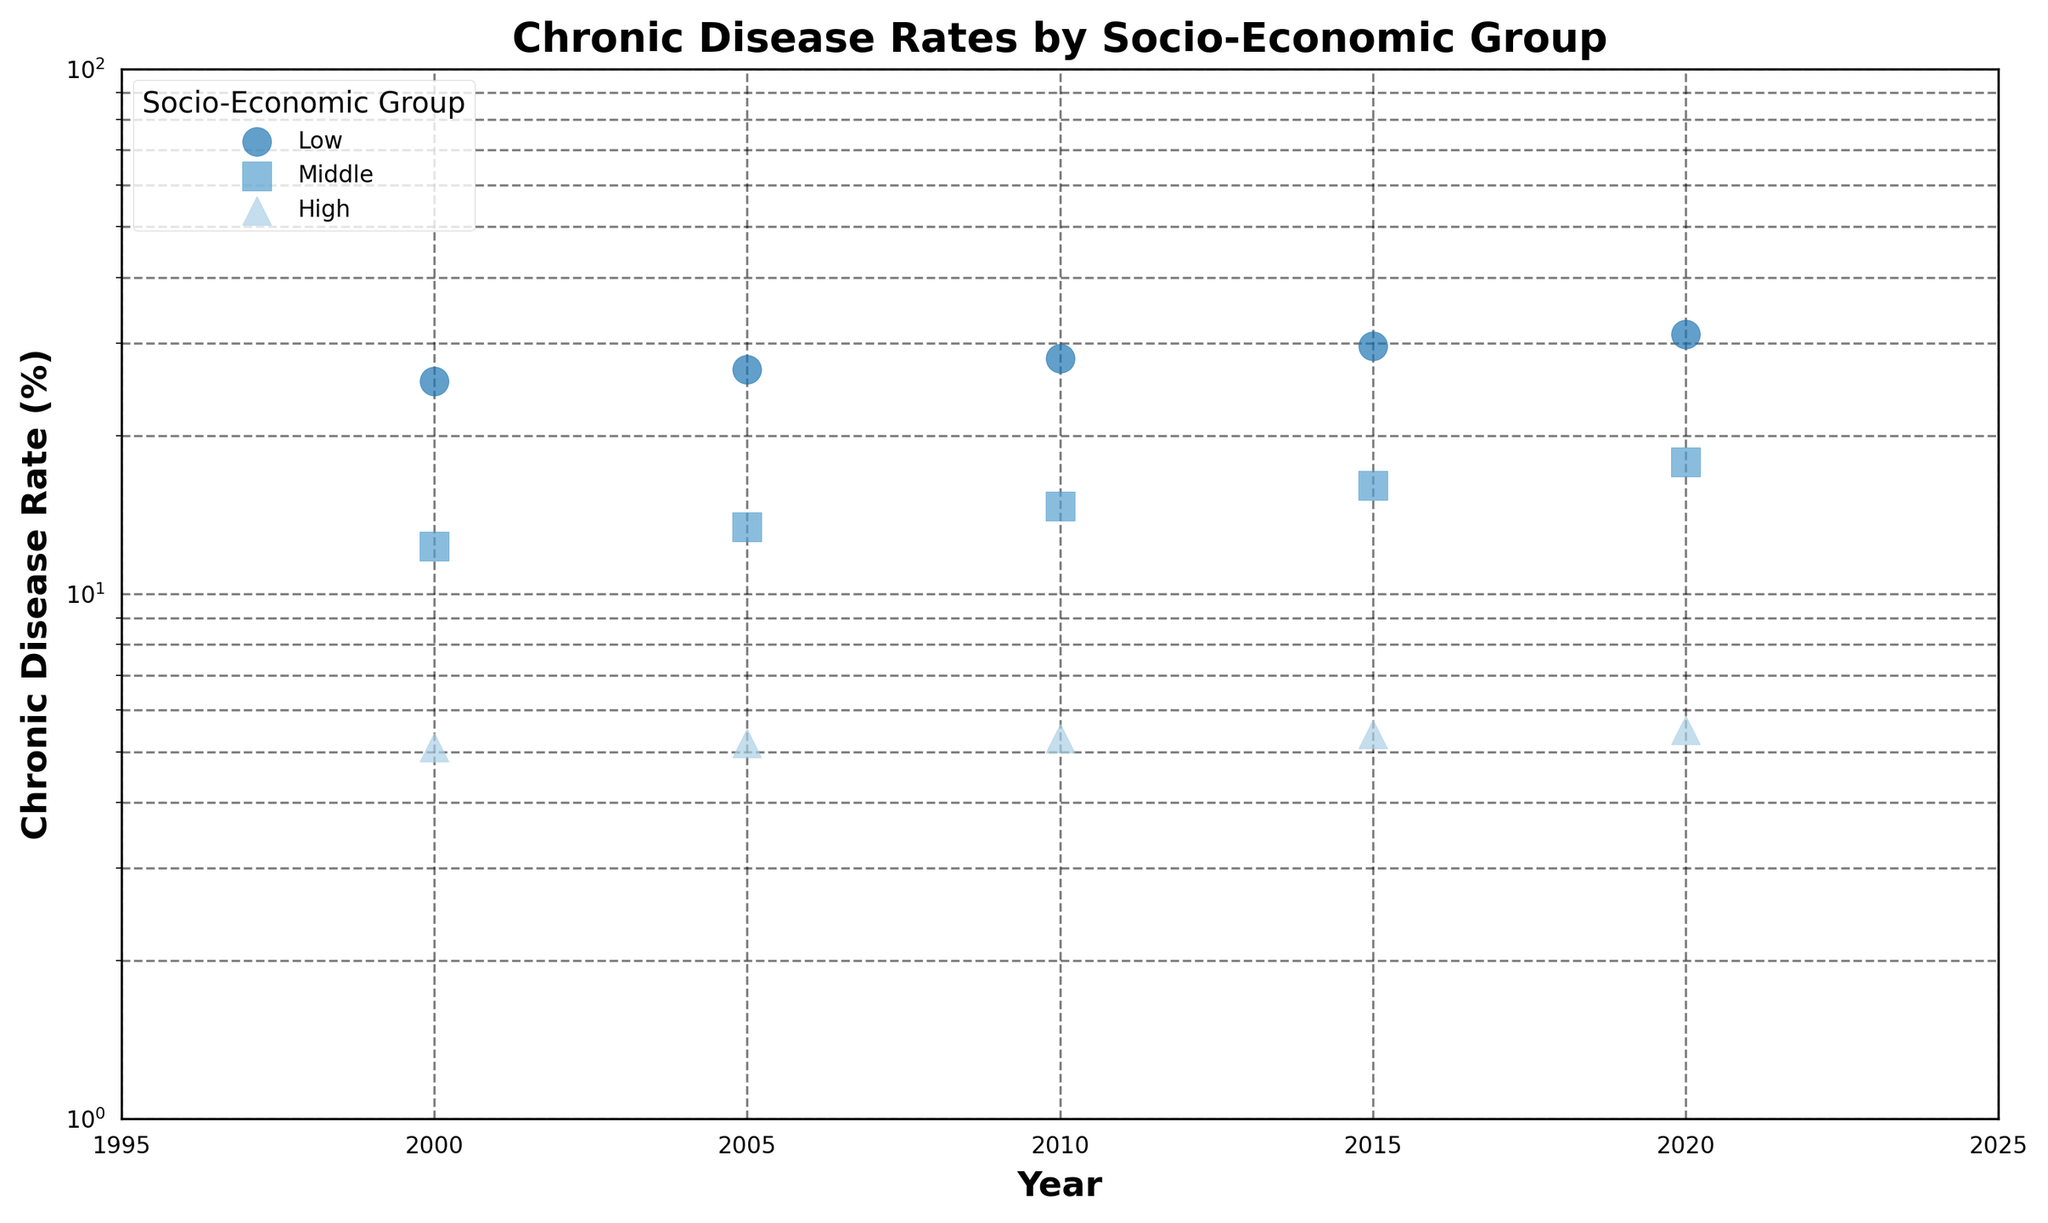What is the title of the scatter plot? The title is located at the top of the figure and usually gives a brief description of what the plot is about. In this case, the title provides an overview of the data being visualized.
Answer: Chronic Disease Rates by Socio-Economic Group Which socio-economic group has the highest chronic disease rate in the year 2000? By observing the data points for the year 2000, identify the one with the highest position on the vertical axis, which represents the chronic disease rate.
Answer: Low How have the chronic disease rates for the Middle group changed from 2000 to 2020? Observe the data points corresponding to the Middle group from the year 2000 to 2020 on the x-axis and compare their vertical positions on the y-axis. The rates have steadily increased over time.
Answer: Increased What is the chronic disease rate for the High socio-economic group in 2015? Locate the data point for the High socio-economic group on the 2015 mark of the x-axis and read its corresponding value on the y-axis.
Answer: 5.4% Between which consecutive years does the Low socio-economic group show the most significant increase in chronic disease rate? Compare the rates at each consecutive year interval for the Low socio-economic group to find the biggest difference. The difference between 2015 and 2020 is the largest.
Answer: 2015 to 2020 Which socio-economic group has the smallest increase in chronic disease rates over the period shown? Compare the start and end values for each socio-economic group to determine which has the smallest difference. The High group shows the smallest increase.
Answer: High How much did the chronic disease rate for the Low socio-economic group increase from 2000 to 2020? Subtract the value in 2000 from the value in 2020 for the Low group to find the increase. The increase is 31.2 - 25.4 = 5.8.
Answer: 5.8% By what factor did the chronic disease rate for the Middle socio-economic group change from 2000 to 2020? Divide the value in 2020 by the value in 2000 for the Middle group: 17.8 / 12.3.
Answer: ~1.45 Are there any group-specific markers used in the plot? If so, what are they? Each socio-economic group is represented by a different marker shape. By observing the scatter plot, we see that 'o' is used for Low, 's' for Middle, and '^' for High.
Answer: Yes, 'o' for Low, 's' for Middle, and '^' for High Does the log scale on the y-axis affect the interpretation of the chronic disease rate trends? The log scale makes it easier to visualize changes over a wide range of values and highlights relative changes, especially for smaller rates which can be more challenging to discern on a linear scale.
Answer: Yes 